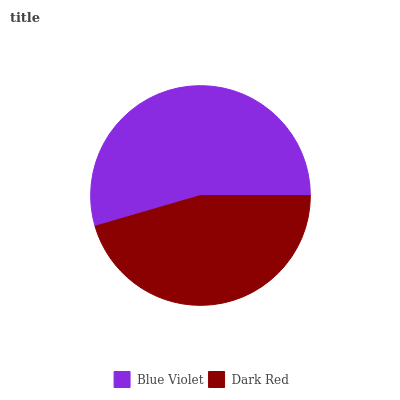Is Dark Red the minimum?
Answer yes or no. Yes. Is Blue Violet the maximum?
Answer yes or no. Yes. Is Dark Red the maximum?
Answer yes or no. No. Is Blue Violet greater than Dark Red?
Answer yes or no. Yes. Is Dark Red less than Blue Violet?
Answer yes or no. Yes. Is Dark Red greater than Blue Violet?
Answer yes or no. No. Is Blue Violet less than Dark Red?
Answer yes or no. No. Is Blue Violet the high median?
Answer yes or no. Yes. Is Dark Red the low median?
Answer yes or no. Yes. Is Dark Red the high median?
Answer yes or no. No. Is Blue Violet the low median?
Answer yes or no. No. 